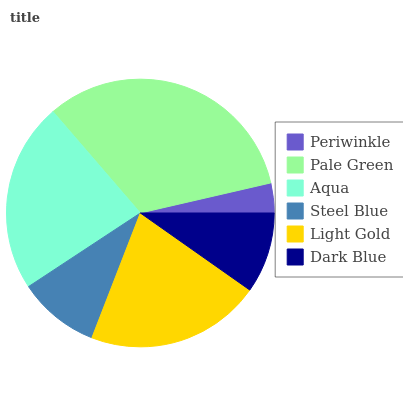Is Periwinkle the minimum?
Answer yes or no. Yes. Is Pale Green the maximum?
Answer yes or no. Yes. Is Aqua the minimum?
Answer yes or no. No. Is Aqua the maximum?
Answer yes or no. No. Is Pale Green greater than Aqua?
Answer yes or no. Yes. Is Aqua less than Pale Green?
Answer yes or no. Yes. Is Aqua greater than Pale Green?
Answer yes or no. No. Is Pale Green less than Aqua?
Answer yes or no. No. Is Light Gold the high median?
Answer yes or no. Yes. Is Steel Blue the low median?
Answer yes or no. Yes. Is Dark Blue the high median?
Answer yes or no. No. Is Dark Blue the low median?
Answer yes or no. No. 